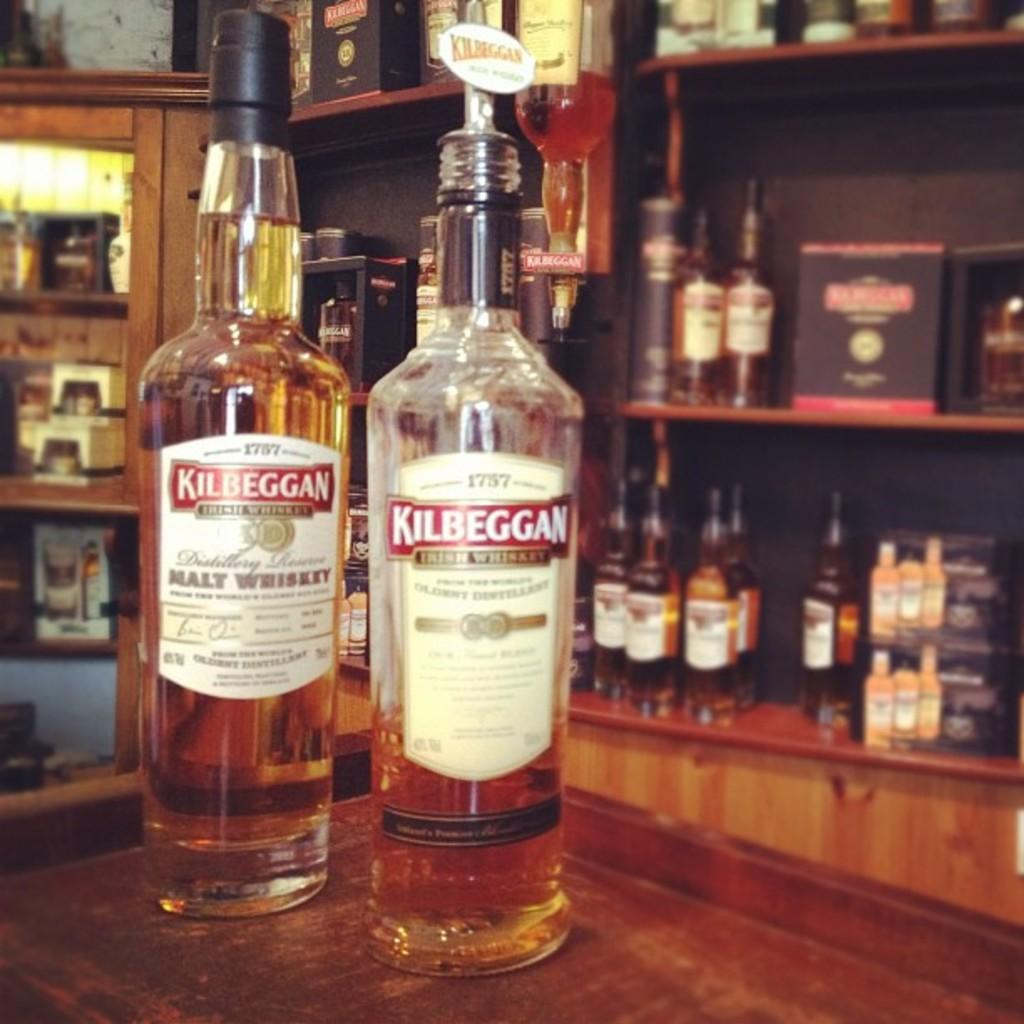Provide a one-sentence caption for the provided image. Two bottles of kilbeggan on a bar counter. 